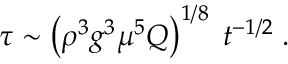<formula> <loc_0><loc_0><loc_500><loc_500>\tau \sim \left ( \rho ^ { 3 } g ^ { 3 } \mu ^ { 5 } Q \right ) ^ { 1 / 8 } \, t ^ { - 1 / 2 } \, .</formula> 